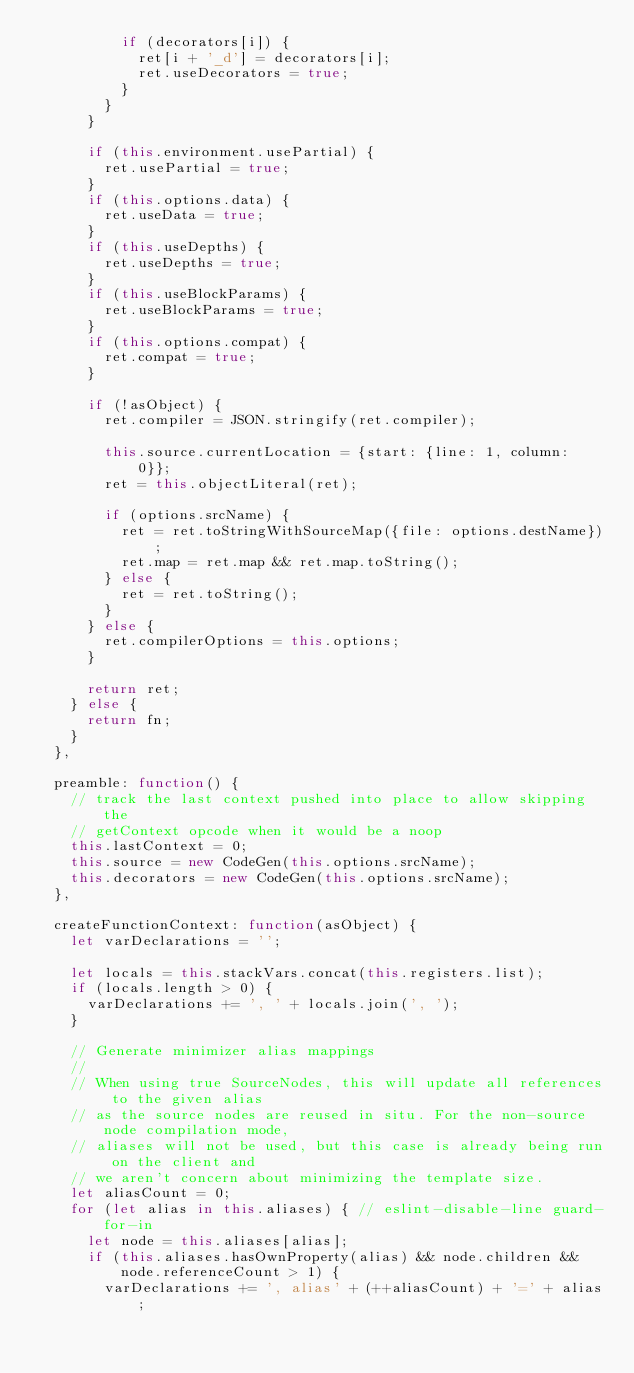<code> <loc_0><loc_0><loc_500><loc_500><_JavaScript_>          if (decorators[i]) {
            ret[i + '_d'] = decorators[i];
            ret.useDecorators = true;
          }
        }
      }

      if (this.environment.usePartial) {
        ret.usePartial = true;
      }
      if (this.options.data) {
        ret.useData = true;
      }
      if (this.useDepths) {
        ret.useDepths = true;
      }
      if (this.useBlockParams) {
        ret.useBlockParams = true;
      }
      if (this.options.compat) {
        ret.compat = true;
      }

      if (!asObject) {
        ret.compiler = JSON.stringify(ret.compiler);

        this.source.currentLocation = {start: {line: 1, column: 0}};
        ret = this.objectLiteral(ret);

        if (options.srcName) {
          ret = ret.toStringWithSourceMap({file: options.destName});
          ret.map = ret.map && ret.map.toString();
        } else {
          ret = ret.toString();
        }
      } else {
        ret.compilerOptions = this.options;
      }

      return ret;
    } else {
      return fn;
    }
  },

  preamble: function() {
    // track the last context pushed into place to allow skipping the
    // getContext opcode when it would be a noop
    this.lastContext = 0;
    this.source = new CodeGen(this.options.srcName);
    this.decorators = new CodeGen(this.options.srcName);
  },

  createFunctionContext: function(asObject) {
    let varDeclarations = '';

    let locals = this.stackVars.concat(this.registers.list);
    if (locals.length > 0) {
      varDeclarations += ', ' + locals.join(', ');
    }

    // Generate minimizer alias mappings
    //
    // When using true SourceNodes, this will update all references to the given alias
    // as the source nodes are reused in situ. For the non-source node compilation mode,
    // aliases will not be used, but this case is already being run on the client and
    // we aren't concern about minimizing the template size.
    let aliasCount = 0;
    for (let alias in this.aliases) { // eslint-disable-line guard-for-in
      let node = this.aliases[alias];
      if (this.aliases.hasOwnProperty(alias) && node.children && node.referenceCount > 1) {
        varDeclarations += ', alias' + (++aliasCount) + '=' + alias;</code> 